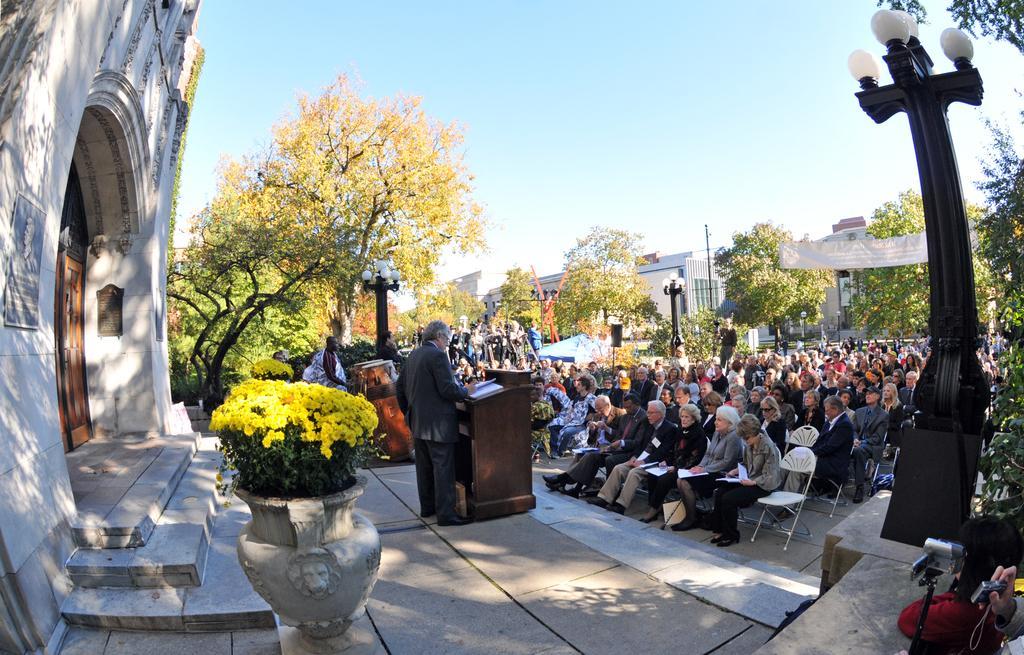Describe this image in one or two sentences. On the left side there is a building with door and steps. Near to that there is a pot with flowering plants. Near to that there are two persons standing. In front of them there are podiums. Also there are light poles. In the back there are trees and buildings. And many people are sitting on chairs. In the background there is sky. On the right corner we can see cameras. 